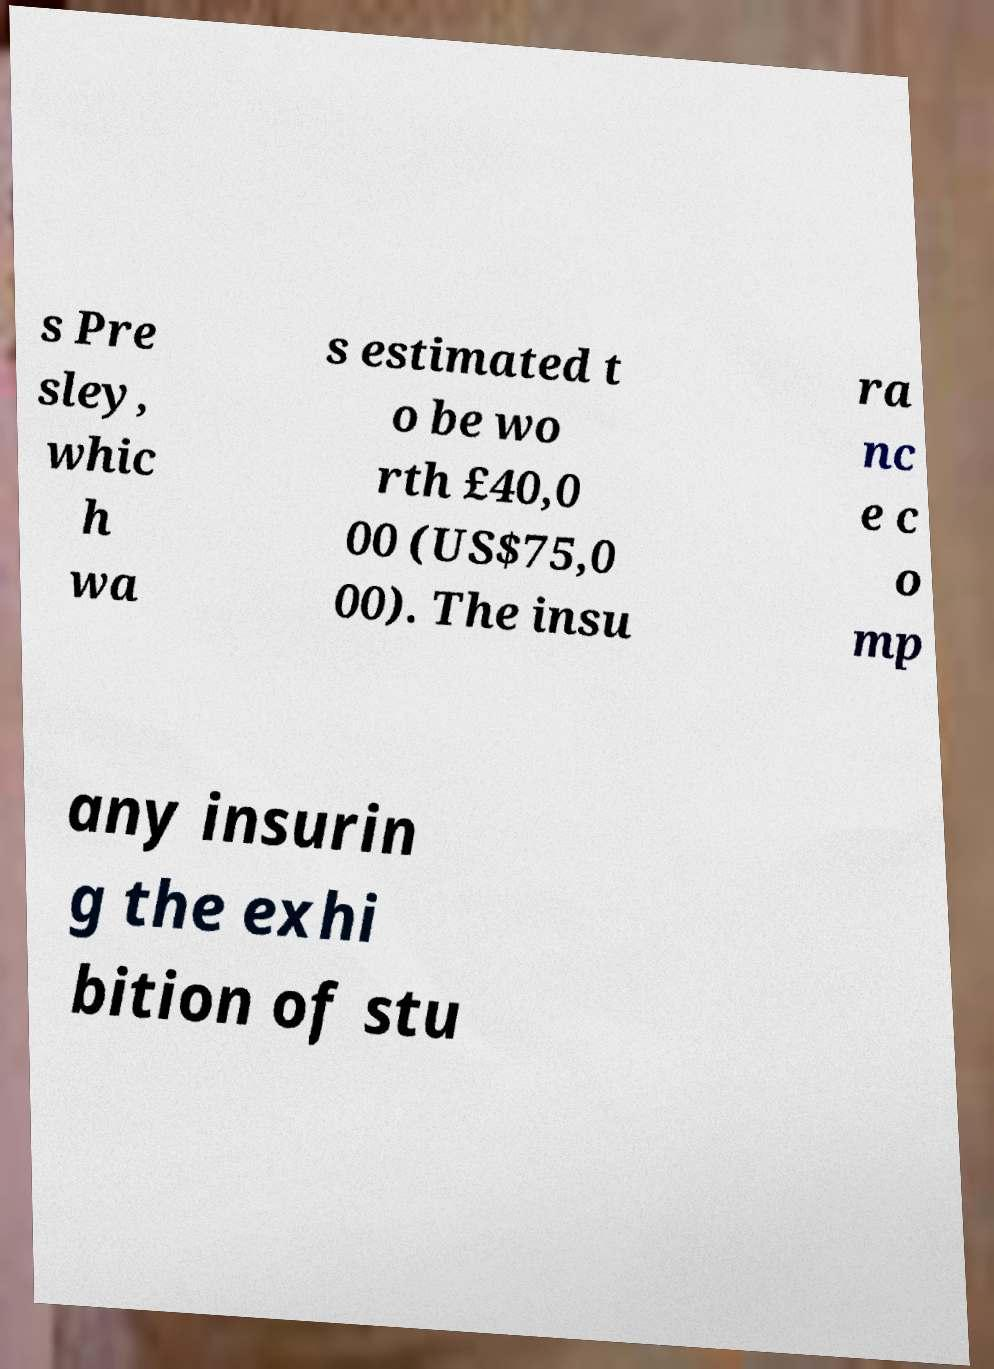For documentation purposes, I need the text within this image transcribed. Could you provide that? s Pre sley, whic h wa s estimated t o be wo rth £40,0 00 (US$75,0 00). The insu ra nc e c o mp any insurin g the exhi bition of stu 